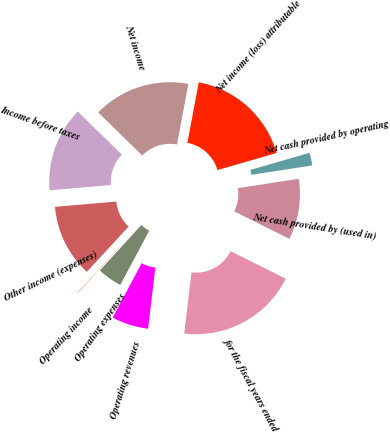<chart> <loc_0><loc_0><loc_500><loc_500><pie_chart><fcel>for the fiscal years ended<fcel>Operating revenues<fcel>Operating expenses<fcel>Operating income<fcel>Other income (expenses)<fcel>Income before taxes<fcel>Net income<fcel>Net income (loss) attributable<fcel>Net cash provided by operating<fcel>Net cash provided by (used in)<nl><fcel>19.51%<fcel>5.93%<fcel>3.99%<fcel>0.1%<fcel>11.75%<fcel>13.69%<fcel>15.63%<fcel>17.57%<fcel>2.05%<fcel>9.81%<nl></chart> 